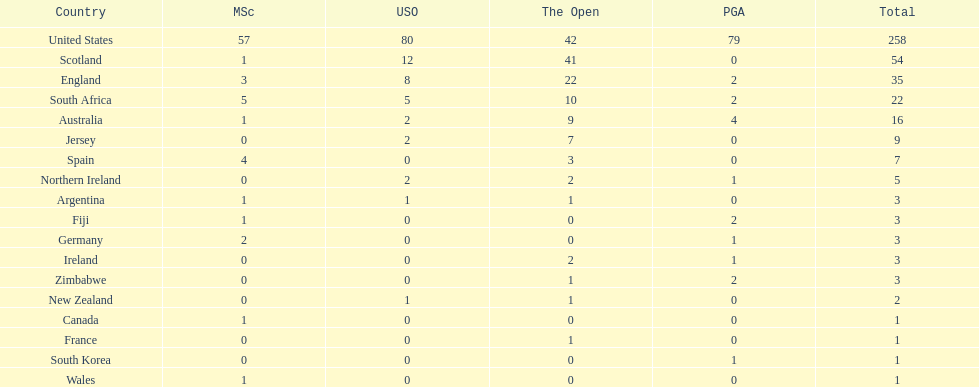Combined, how many winning golfers does england and wales have in the masters? 4. 